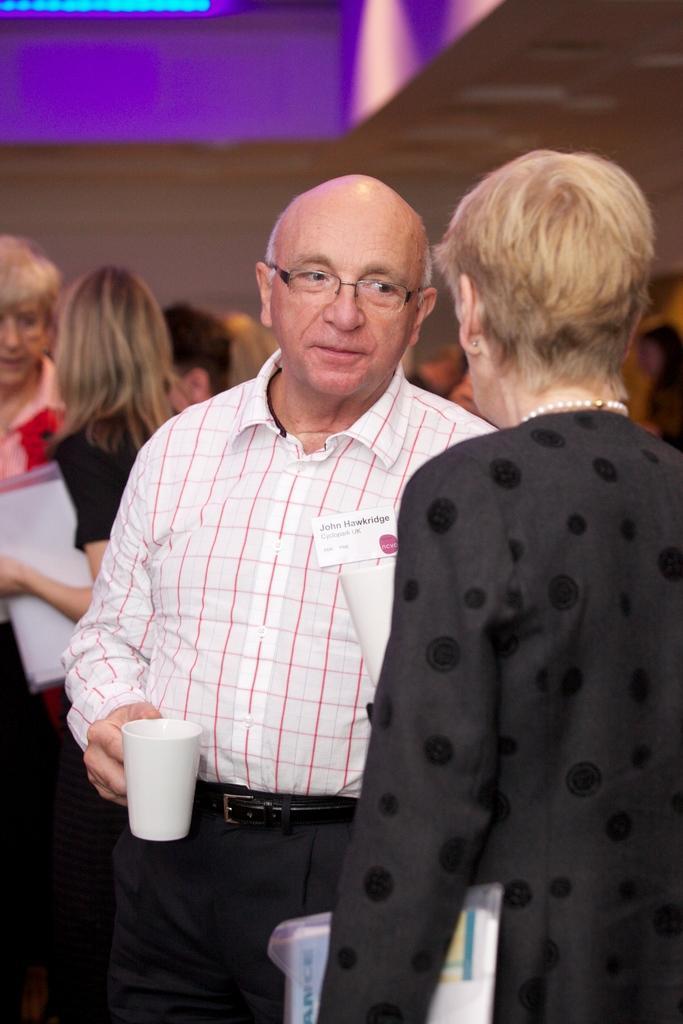In one or two sentences, can you explain what this image depicts? At the top we can see the ceiling and light. In this picture we can see the people. In this picture we can see a woman in a black dress, is holding a file in her hand. We can see a man wearing a shirt, spectacles and he is holding a white cup in his hand. on the right side of the picture we can see a woman wearing a pearl chain and she is holding a file. 